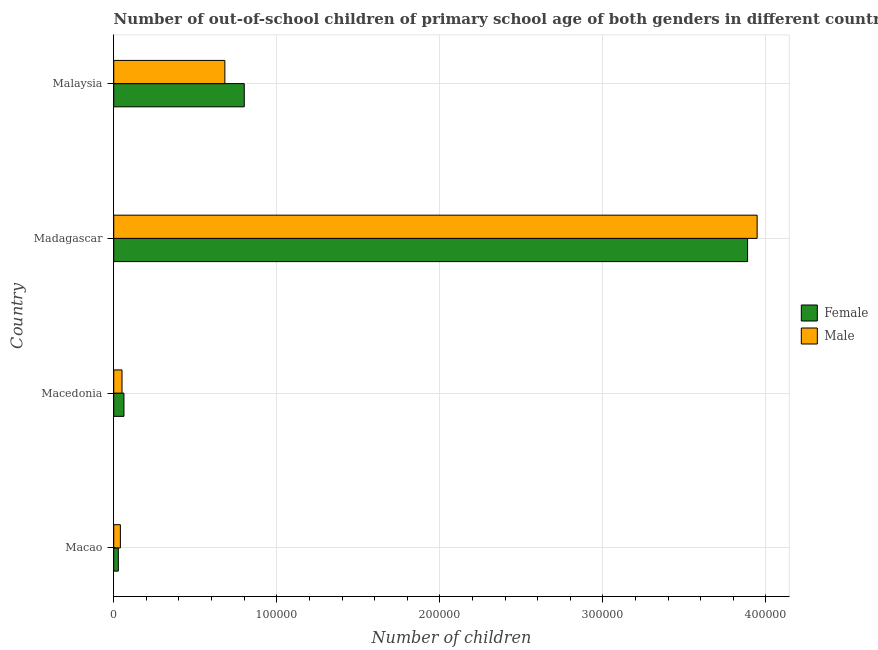How many different coloured bars are there?
Offer a very short reply. 2. How many groups of bars are there?
Your answer should be compact. 4. Are the number of bars on each tick of the Y-axis equal?
Your answer should be very brief. Yes. What is the label of the 3rd group of bars from the top?
Your response must be concise. Macedonia. In how many cases, is the number of bars for a given country not equal to the number of legend labels?
Your answer should be compact. 0. What is the number of male out-of-school students in Malaysia?
Offer a very short reply. 6.82e+04. Across all countries, what is the maximum number of male out-of-school students?
Keep it short and to the point. 3.95e+05. Across all countries, what is the minimum number of female out-of-school students?
Keep it short and to the point. 2815. In which country was the number of female out-of-school students maximum?
Keep it short and to the point. Madagascar. In which country was the number of male out-of-school students minimum?
Give a very brief answer. Macao. What is the total number of male out-of-school students in the graph?
Offer a very short reply. 4.72e+05. What is the difference between the number of male out-of-school students in Macedonia and that in Madagascar?
Ensure brevity in your answer.  -3.90e+05. What is the difference between the number of male out-of-school students in Malaysia and the number of female out-of-school students in Macedonia?
Your response must be concise. 6.19e+04. What is the average number of male out-of-school students per country?
Give a very brief answer. 1.18e+05. What is the difference between the number of male out-of-school students and number of female out-of-school students in Macao?
Offer a terse response. 1261. Is the number of female out-of-school students in Madagascar less than that in Malaysia?
Your response must be concise. No. What is the difference between the highest and the second highest number of male out-of-school students?
Offer a very short reply. 3.26e+05. What is the difference between the highest and the lowest number of female out-of-school students?
Provide a succinct answer. 3.86e+05. In how many countries, is the number of female out-of-school students greater than the average number of female out-of-school students taken over all countries?
Provide a short and direct response. 1. Is the sum of the number of male out-of-school students in Macao and Malaysia greater than the maximum number of female out-of-school students across all countries?
Ensure brevity in your answer.  No. How many bars are there?
Provide a succinct answer. 8. Are all the bars in the graph horizontal?
Provide a short and direct response. Yes. Does the graph contain grids?
Offer a terse response. Yes. Where does the legend appear in the graph?
Make the answer very short. Center right. How many legend labels are there?
Offer a very short reply. 2. What is the title of the graph?
Make the answer very short. Number of out-of-school children of primary school age of both genders in different countries. What is the label or title of the X-axis?
Provide a succinct answer. Number of children. What is the Number of children of Female in Macao?
Offer a terse response. 2815. What is the Number of children in Male in Macao?
Provide a succinct answer. 4076. What is the Number of children of Female in Macedonia?
Your answer should be compact. 6259. What is the Number of children of Male in Macedonia?
Offer a very short reply. 5079. What is the Number of children in Female in Madagascar?
Provide a short and direct response. 3.89e+05. What is the Number of children of Male in Madagascar?
Provide a succinct answer. 3.95e+05. What is the Number of children of Female in Malaysia?
Provide a succinct answer. 8.01e+04. What is the Number of children in Male in Malaysia?
Make the answer very short. 6.82e+04. Across all countries, what is the maximum Number of children in Female?
Offer a very short reply. 3.89e+05. Across all countries, what is the maximum Number of children of Male?
Keep it short and to the point. 3.95e+05. Across all countries, what is the minimum Number of children of Female?
Keep it short and to the point. 2815. Across all countries, what is the minimum Number of children of Male?
Offer a terse response. 4076. What is the total Number of children in Female in the graph?
Your answer should be very brief. 4.78e+05. What is the total Number of children in Male in the graph?
Offer a very short reply. 4.72e+05. What is the difference between the Number of children in Female in Macao and that in Macedonia?
Your answer should be very brief. -3444. What is the difference between the Number of children in Male in Macao and that in Macedonia?
Make the answer very short. -1003. What is the difference between the Number of children in Female in Macao and that in Madagascar?
Ensure brevity in your answer.  -3.86e+05. What is the difference between the Number of children of Male in Macao and that in Madagascar?
Keep it short and to the point. -3.91e+05. What is the difference between the Number of children in Female in Macao and that in Malaysia?
Keep it short and to the point. -7.72e+04. What is the difference between the Number of children of Male in Macao and that in Malaysia?
Make the answer very short. -6.41e+04. What is the difference between the Number of children in Female in Macedonia and that in Madagascar?
Your answer should be very brief. -3.82e+05. What is the difference between the Number of children of Male in Macedonia and that in Madagascar?
Your answer should be very brief. -3.90e+05. What is the difference between the Number of children in Female in Macedonia and that in Malaysia?
Your response must be concise. -7.38e+04. What is the difference between the Number of children in Male in Macedonia and that in Malaysia?
Offer a very short reply. -6.31e+04. What is the difference between the Number of children in Female in Madagascar and that in Malaysia?
Keep it short and to the point. 3.09e+05. What is the difference between the Number of children of Male in Madagascar and that in Malaysia?
Offer a very short reply. 3.26e+05. What is the difference between the Number of children of Female in Macao and the Number of children of Male in Macedonia?
Give a very brief answer. -2264. What is the difference between the Number of children in Female in Macao and the Number of children in Male in Madagascar?
Offer a terse response. -3.92e+05. What is the difference between the Number of children of Female in Macao and the Number of children of Male in Malaysia?
Make the answer very short. -6.53e+04. What is the difference between the Number of children in Female in Macedonia and the Number of children in Male in Madagascar?
Your answer should be very brief. -3.88e+05. What is the difference between the Number of children in Female in Macedonia and the Number of children in Male in Malaysia?
Your answer should be very brief. -6.19e+04. What is the difference between the Number of children in Female in Madagascar and the Number of children in Male in Malaysia?
Provide a short and direct response. 3.21e+05. What is the average Number of children of Female per country?
Provide a short and direct response. 1.19e+05. What is the average Number of children in Male per country?
Provide a short and direct response. 1.18e+05. What is the difference between the Number of children of Female and Number of children of Male in Macao?
Provide a short and direct response. -1261. What is the difference between the Number of children in Female and Number of children in Male in Macedonia?
Provide a succinct answer. 1180. What is the difference between the Number of children of Female and Number of children of Male in Madagascar?
Keep it short and to the point. -5847. What is the difference between the Number of children in Female and Number of children in Male in Malaysia?
Ensure brevity in your answer.  1.19e+04. What is the ratio of the Number of children of Female in Macao to that in Macedonia?
Your answer should be very brief. 0.45. What is the ratio of the Number of children of Male in Macao to that in Macedonia?
Your answer should be compact. 0.8. What is the ratio of the Number of children of Female in Macao to that in Madagascar?
Make the answer very short. 0.01. What is the ratio of the Number of children in Male in Macao to that in Madagascar?
Your response must be concise. 0.01. What is the ratio of the Number of children in Female in Macao to that in Malaysia?
Make the answer very short. 0.04. What is the ratio of the Number of children in Male in Macao to that in Malaysia?
Provide a short and direct response. 0.06. What is the ratio of the Number of children in Female in Macedonia to that in Madagascar?
Your answer should be very brief. 0.02. What is the ratio of the Number of children in Male in Macedonia to that in Madagascar?
Offer a terse response. 0.01. What is the ratio of the Number of children in Female in Macedonia to that in Malaysia?
Your response must be concise. 0.08. What is the ratio of the Number of children in Male in Macedonia to that in Malaysia?
Provide a short and direct response. 0.07. What is the ratio of the Number of children in Female in Madagascar to that in Malaysia?
Your answer should be compact. 4.86. What is the ratio of the Number of children in Male in Madagascar to that in Malaysia?
Provide a succinct answer. 5.79. What is the difference between the highest and the second highest Number of children in Female?
Provide a short and direct response. 3.09e+05. What is the difference between the highest and the second highest Number of children in Male?
Give a very brief answer. 3.26e+05. What is the difference between the highest and the lowest Number of children of Female?
Give a very brief answer. 3.86e+05. What is the difference between the highest and the lowest Number of children in Male?
Ensure brevity in your answer.  3.91e+05. 